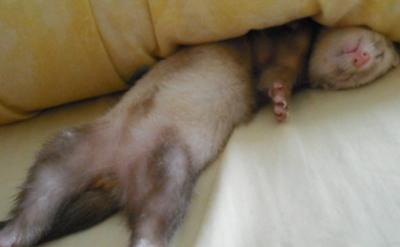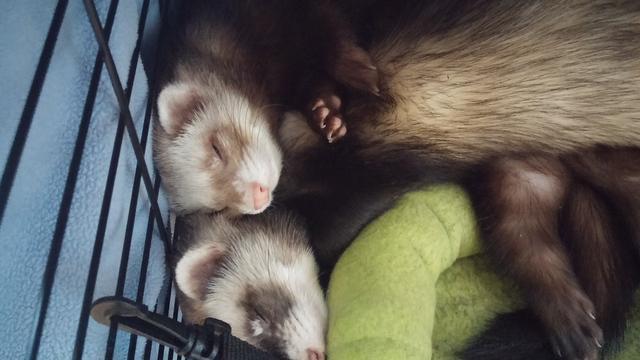The first image is the image on the left, the second image is the image on the right. For the images shown, is this caption "Three ferrets are sleeping." true? Answer yes or no. Yes. The first image is the image on the left, the second image is the image on the right. Examine the images to the left and right. Is the description "In one of the images, exactly one ferret is sleeping with both eyes and mouth closed." accurate? Answer yes or no. Yes. 